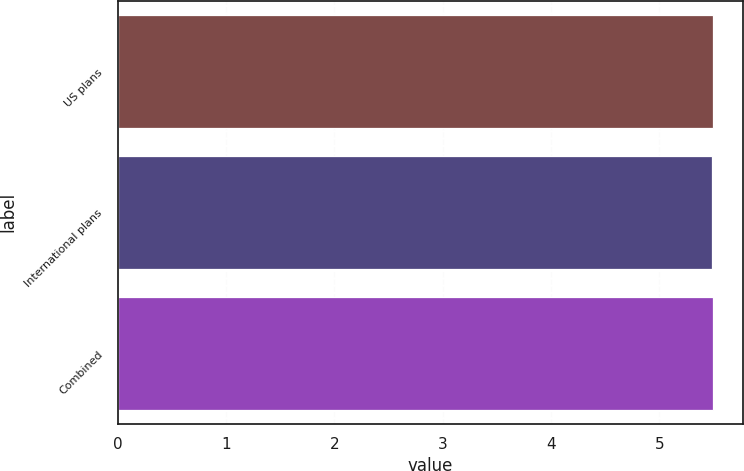Convert chart. <chart><loc_0><loc_0><loc_500><loc_500><bar_chart><fcel>US plans<fcel>International plans<fcel>Combined<nl><fcel>5.5<fcel>5.49<fcel>5.5<nl></chart> 